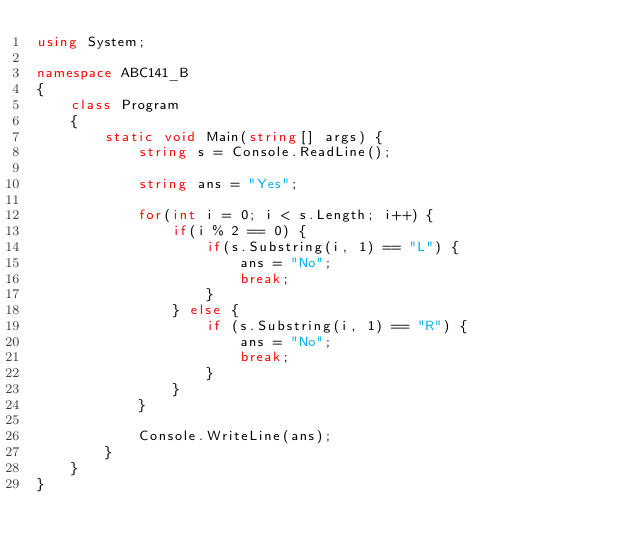Convert code to text. <code><loc_0><loc_0><loc_500><loc_500><_C#_>using System;

namespace ABC141_B
{
    class Program
    {
        static void Main(string[] args) {
            string s = Console.ReadLine();

            string ans = "Yes";

            for(int i = 0; i < s.Length; i++) {
                if(i % 2 == 0) {
                    if(s.Substring(i, 1) == "L") {
                        ans = "No";
                        break;
                    }
                } else {
                    if (s.Substring(i, 1) == "R") {
                        ans = "No";
                        break;
                    }
                }
            }

            Console.WriteLine(ans);
        }
    }
}</code> 